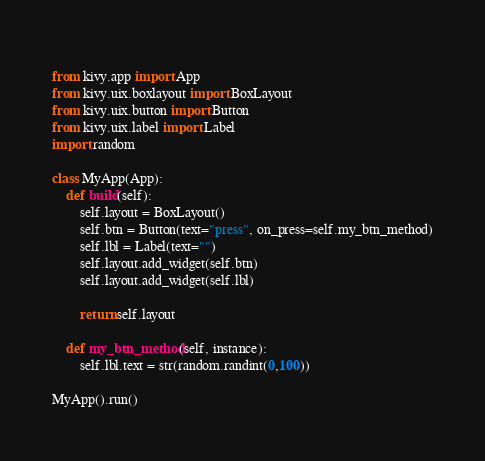<code> <loc_0><loc_0><loc_500><loc_500><_Python_> 
from kivy.app import App
from kivy.uix.boxlayout import BoxLayout
from kivy.uix.button import Button
from kivy.uix.label import Label
import random

class MyApp(App):
    def build(self):
        self.layout = BoxLayout()
        self.btn = Button(text="press", on_press=self.my_btn_method)
        self.lbl = Label(text="")
        self.layout.add_widget(self.btn)
        self.layout.add_widget(self.lbl)

        return self.layout

    def my_btn_method(self, instance):
        self.lbl.text = str(random.randint(0,100))

MyApp().run()
</code> 